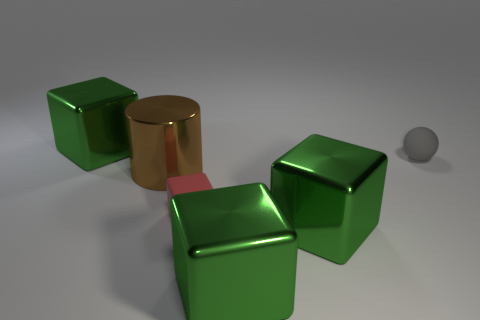Is the material of the brown object the same as the small thing that is in front of the brown thing?
Offer a terse response. No. There is a small gray object that is behind the cylinder on the left side of the gray object; what number of rubber cubes are behind it?
Offer a very short reply. 0. Are there fewer spheres that are on the left side of the small red matte thing than gray balls?
Provide a short and direct response. Yes. Do the large metal cylinder and the matte sphere have the same color?
Your answer should be compact. No. What number of other brown cylinders are made of the same material as the brown cylinder?
Your answer should be compact. 0. Do the small red object on the left side of the tiny sphere and the big brown thing have the same material?
Offer a very short reply. No. Are there an equal number of tiny matte objects that are in front of the gray rubber sphere and large red rubber cubes?
Provide a short and direct response. No. The red matte cube has what size?
Your response must be concise. Small. What number of big blocks have the same color as the cylinder?
Offer a terse response. 0. Do the gray thing and the red rubber thing have the same size?
Your response must be concise. Yes. 